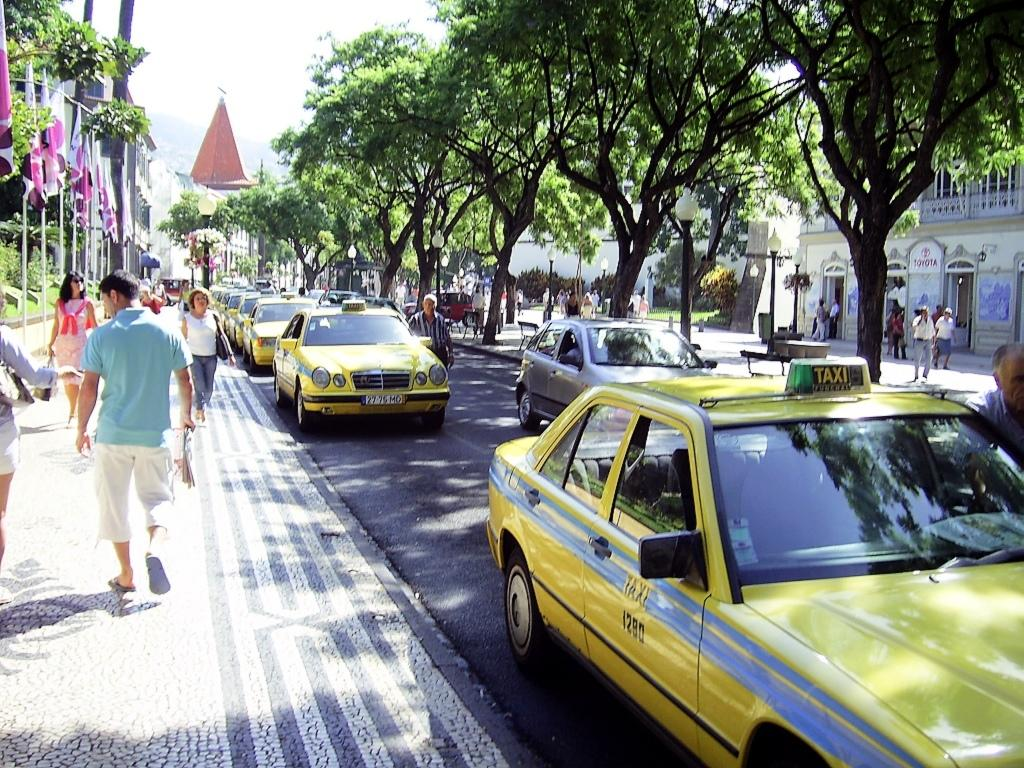<image>
Describe the image concisely. A row of taxi cabs that are yellow that say Taxi on the side. 